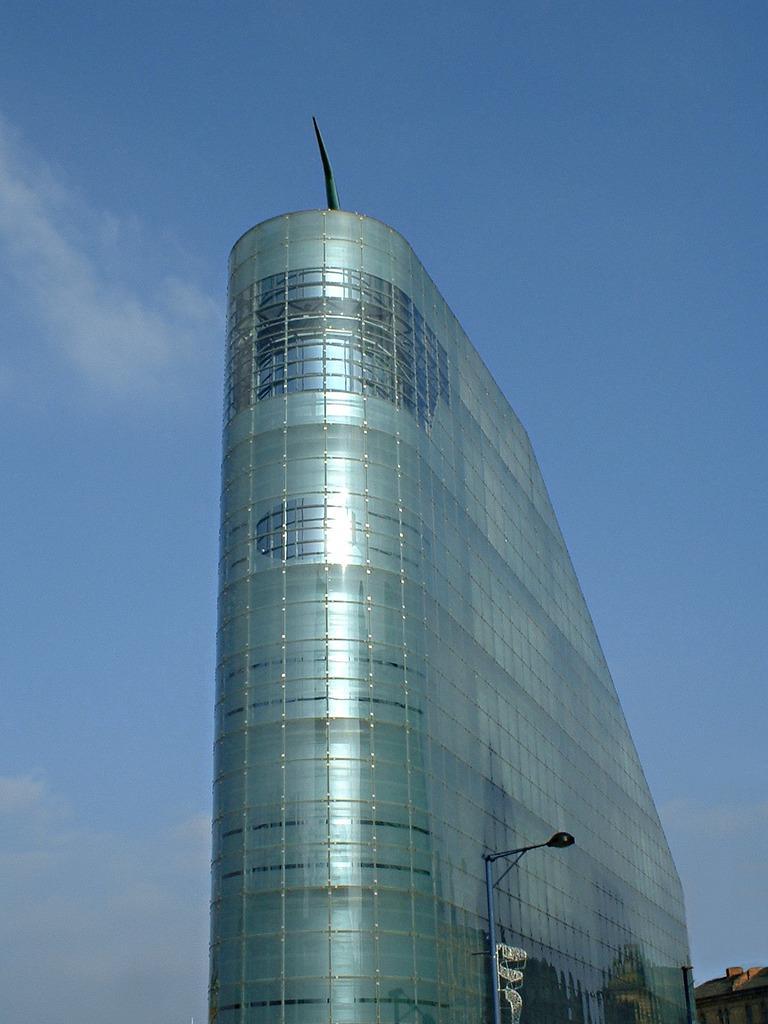Please provide a concise description of this image. This image is taken outdoors. At the top of the image there is the sky with clouds. In the middle of the image there is a skyscraper and there is a pole with a street light. On the right side of the image there is a building. 